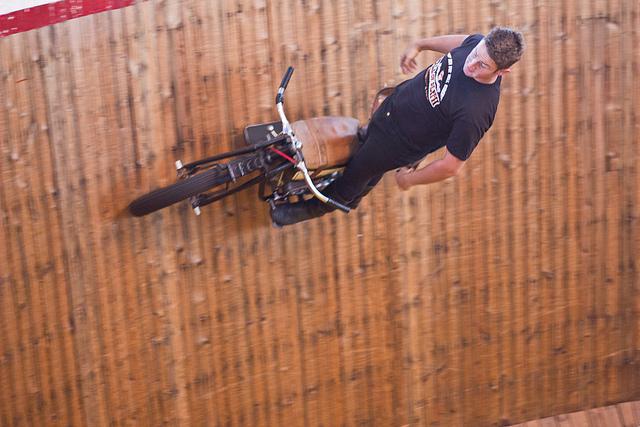What is the man standing near?
Concise answer only. Motorcycle. Is that a scooter?
Answer briefly. No. What color is the man's hair?
Give a very brief answer. Brown. 